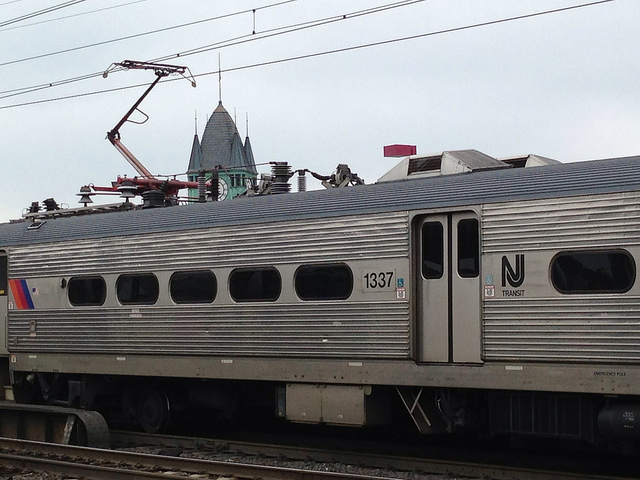Read all the text in this image. 1337 NJ TRANSIT 